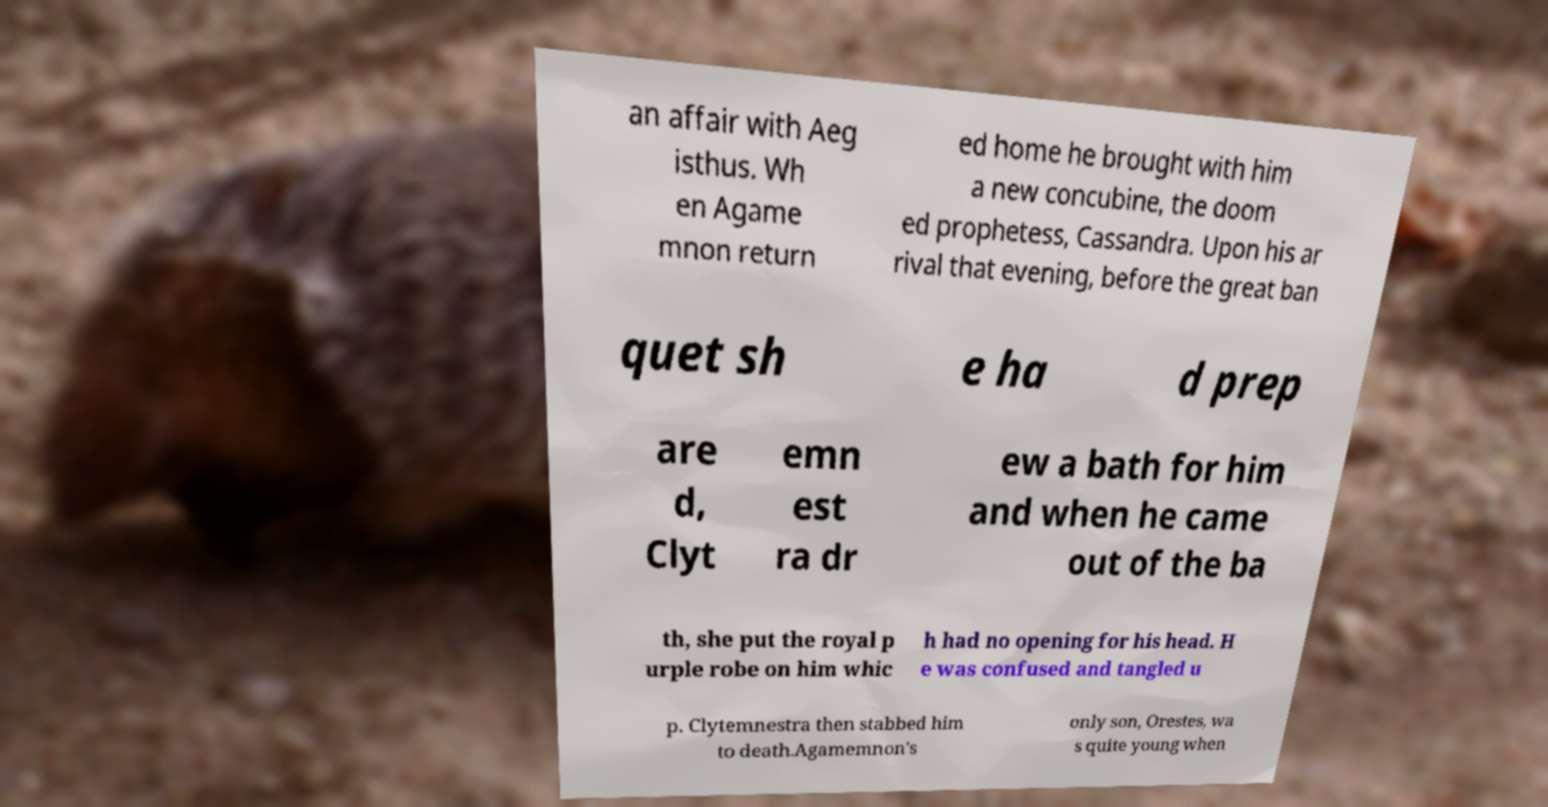Please identify and transcribe the text found in this image. an affair with Aeg isthus. Wh en Agame mnon return ed home he brought with him a new concubine, the doom ed prophetess, Cassandra. Upon his ar rival that evening, before the great ban quet sh e ha d prep are d, Clyt emn est ra dr ew a bath for him and when he came out of the ba th, she put the royal p urple robe on him whic h had no opening for his head. H e was confused and tangled u p. Clytemnestra then stabbed him to death.Agamemnon's only son, Orestes, wa s quite young when 